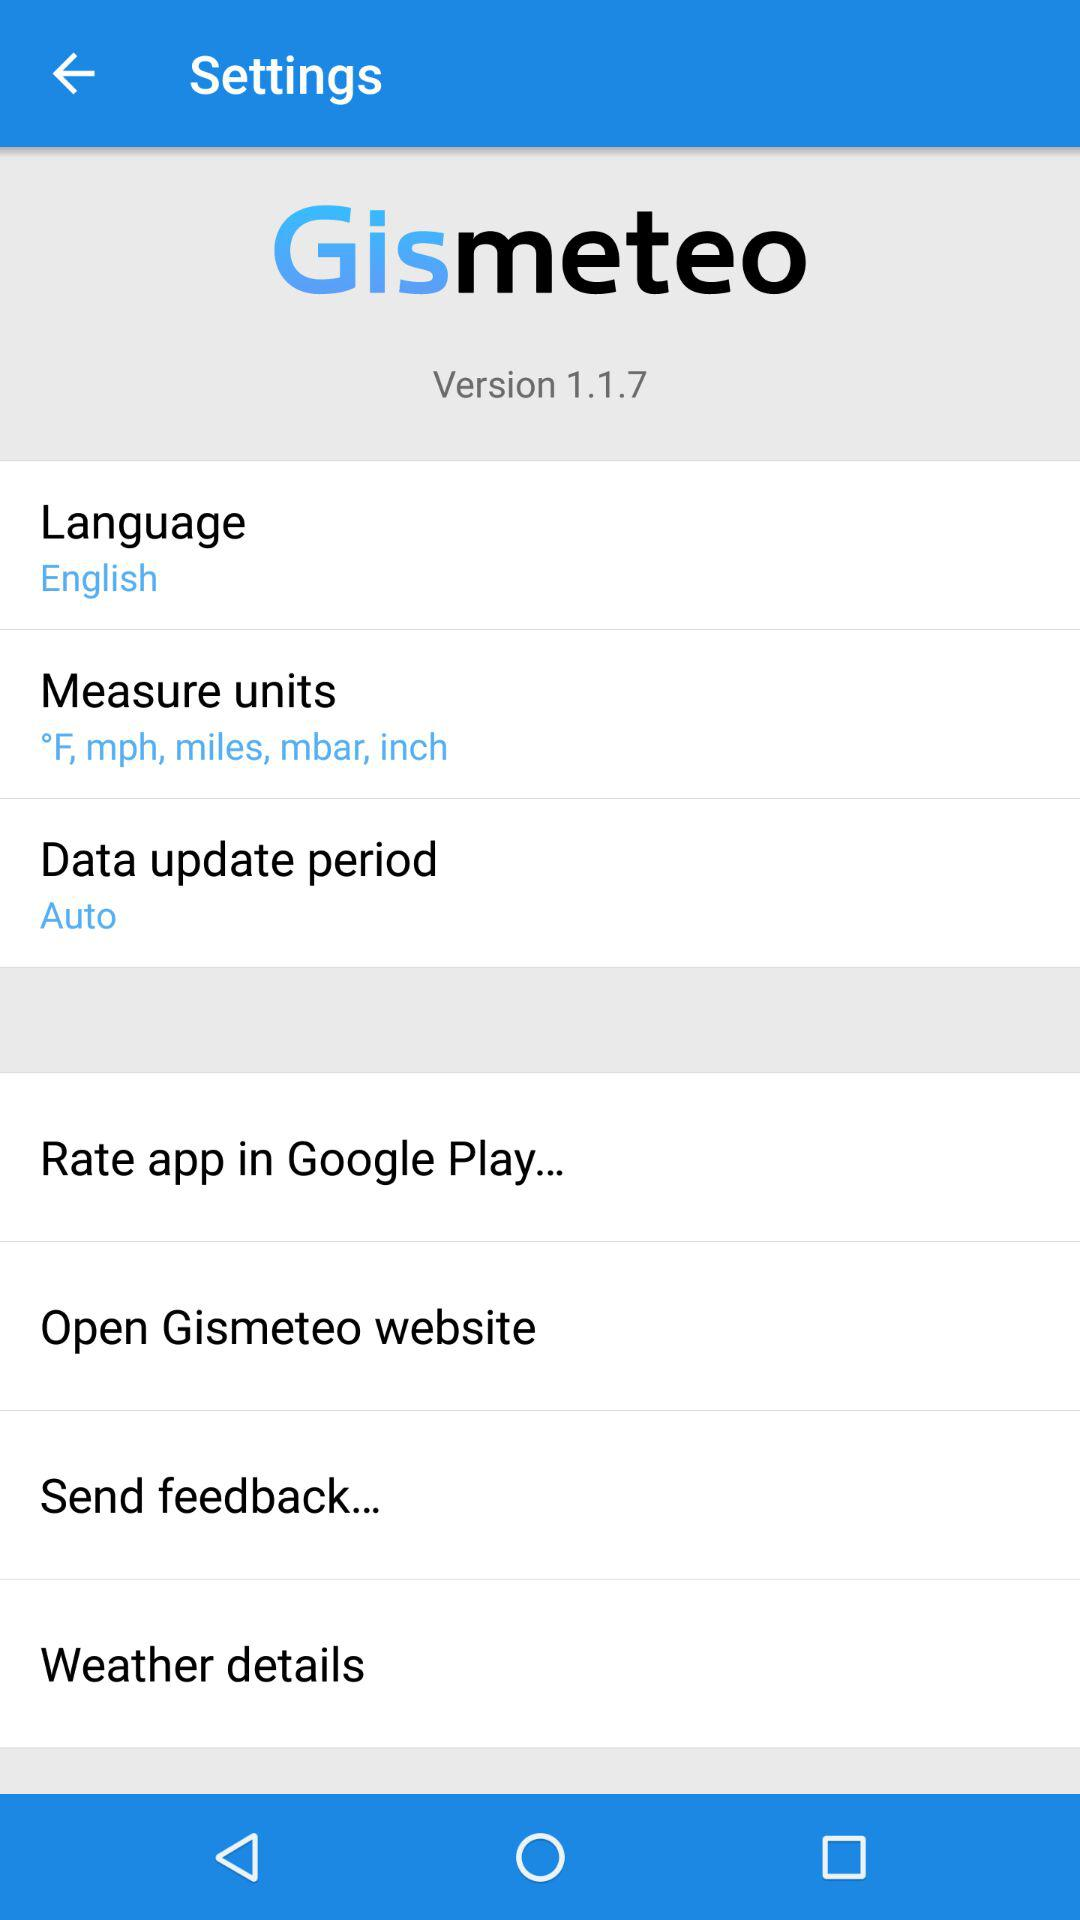What is the setting for the data update period? The setting for the data update period is "Auto". 